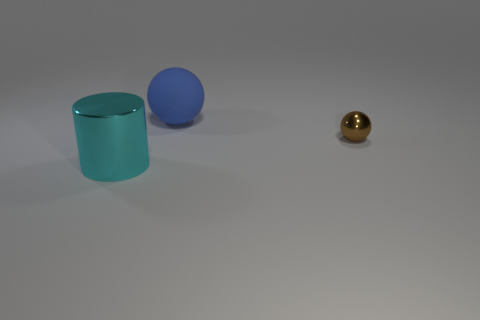Are the tiny thing and the large thing in front of the blue thing made of the same material?
Provide a short and direct response. Yes. The rubber thing that is the same size as the cyan cylinder is what color?
Provide a short and direct response. Blue. What size is the metallic object that is behind the metallic thing in front of the small thing?
Ensure brevity in your answer.  Small. There is a large matte sphere; is its color the same as the sphere that is right of the matte object?
Your answer should be compact. No. Is the number of matte balls that are right of the big blue sphere less than the number of big blue shiny spheres?
Your answer should be very brief. No. What number of other things are there of the same size as the blue sphere?
Provide a succinct answer. 1. Do the big thing that is in front of the big blue thing and the blue rubber object have the same shape?
Keep it short and to the point. No. Are there more big objects that are in front of the metal cylinder than small shiny objects?
Provide a succinct answer. No. There is a thing that is both on the right side of the big shiny thing and to the left of the tiny sphere; what material is it?
Your answer should be very brief. Rubber. Is there any other thing that has the same shape as the large cyan metallic thing?
Your response must be concise. No. 